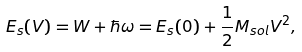Convert formula to latex. <formula><loc_0><loc_0><loc_500><loc_500>E _ { s } ( V ) = W + \hbar { \omega } = E _ { s } ( 0 ) + \frac { 1 } { 2 } M _ { s o l } V ^ { 2 } ,</formula> 